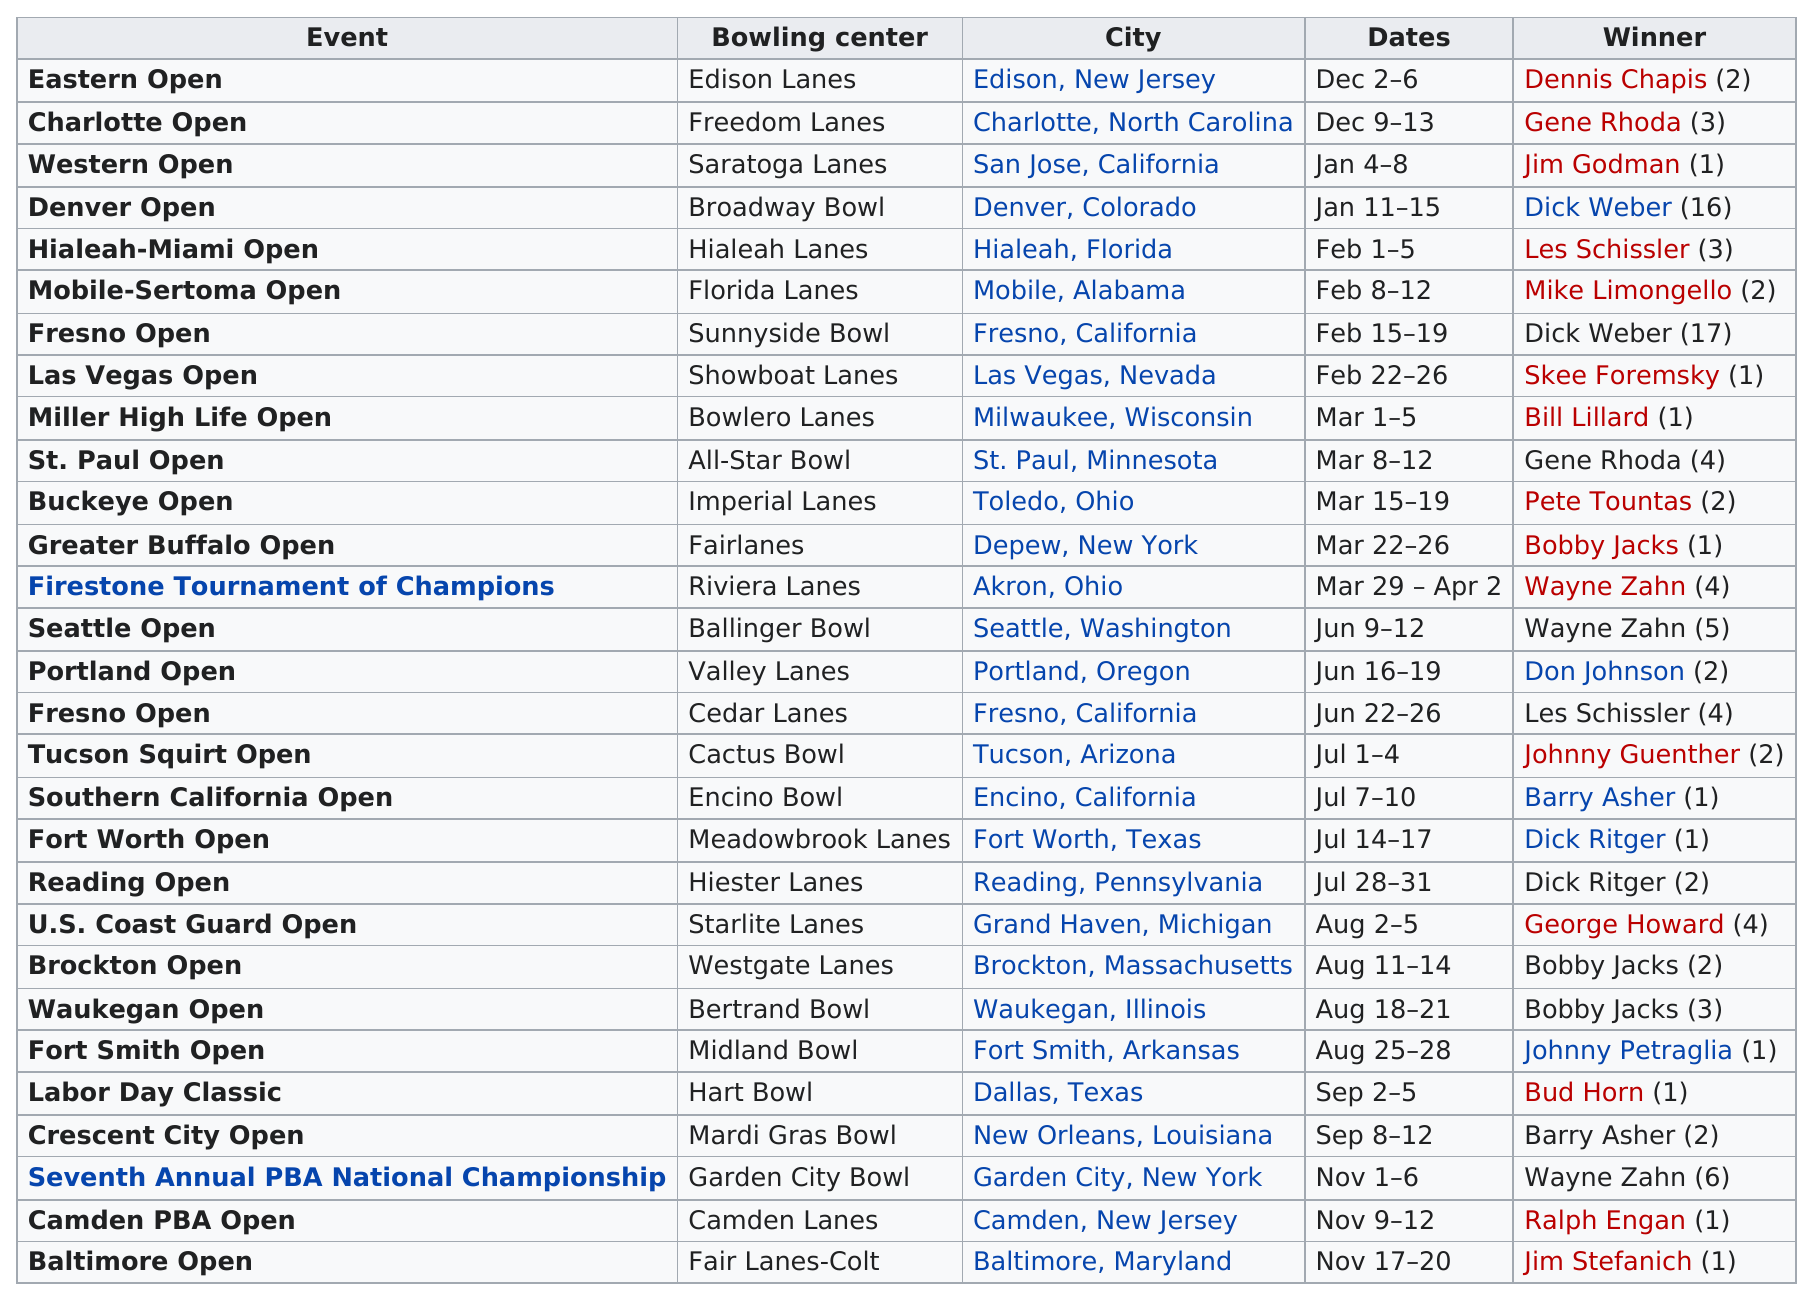Give some essential details in this illustration. After Jim Godman won the Western Open, Dick Weber went on to win the next tournament. The Denver Open took place for a total of 5 days. Gene Rhoda won this season a total of two times, according to the information provided. The last event on the chart is the Baltimore Open. Before the St. Paul Open was held, an event was previously held in Milwaukee, Wisconsin. 